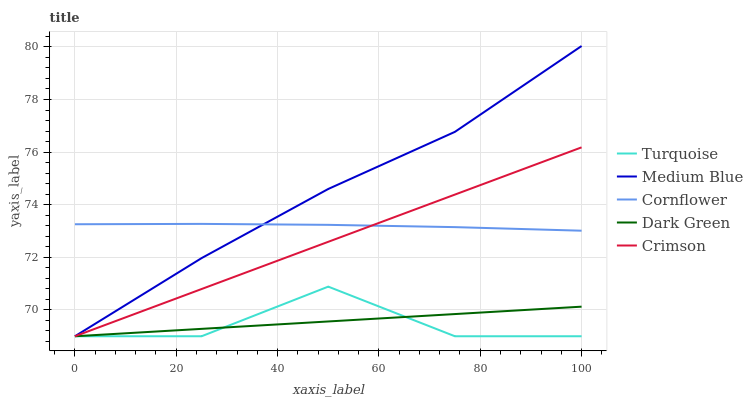Does Cornflower have the minimum area under the curve?
Answer yes or no. No. Does Cornflower have the maximum area under the curve?
Answer yes or no. No. Is Cornflower the smoothest?
Answer yes or no. No. Is Cornflower the roughest?
Answer yes or no. No. Does Cornflower have the lowest value?
Answer yes or no. No. Does Cornflower have the highest value?
Answer yes or no. No. Is Turquoise less than Cornflower?
Answer yes or no. Yes. Is Cornflower greater than Dark Green?
Answer yes or no. Yes. Does Turquoise intersect Cornflower?
Answer yes or no. No. 